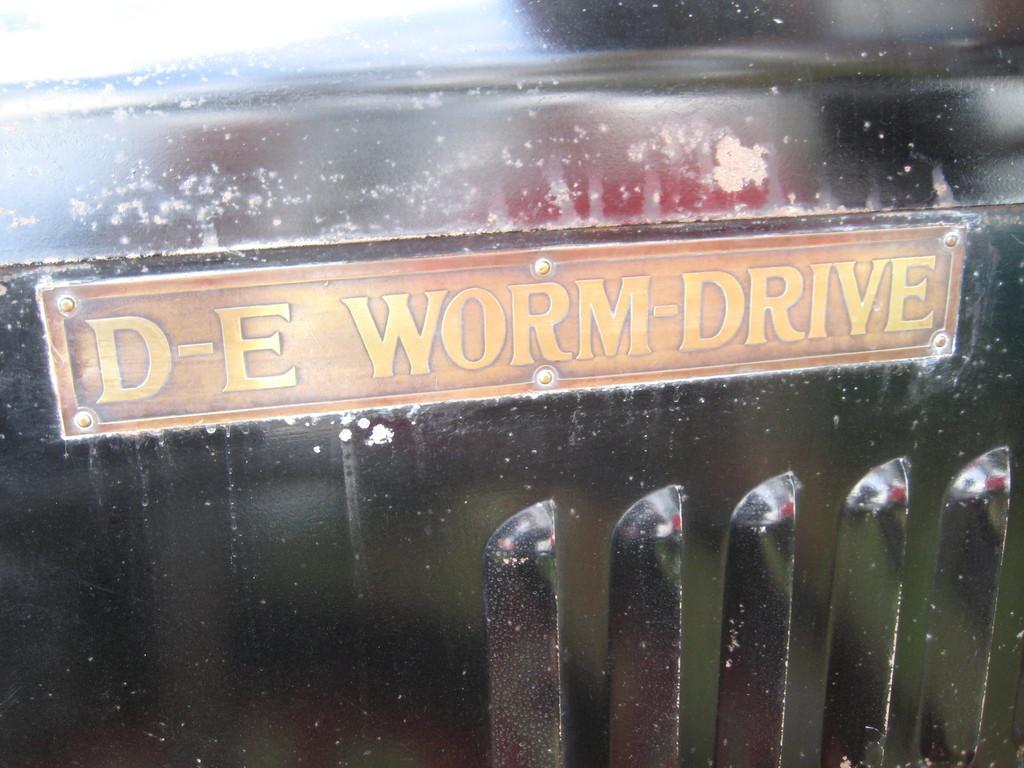Could you give a brief overview of what you see in this image? In this image I can see a black colored object and an orange and yellow colored board to it. 